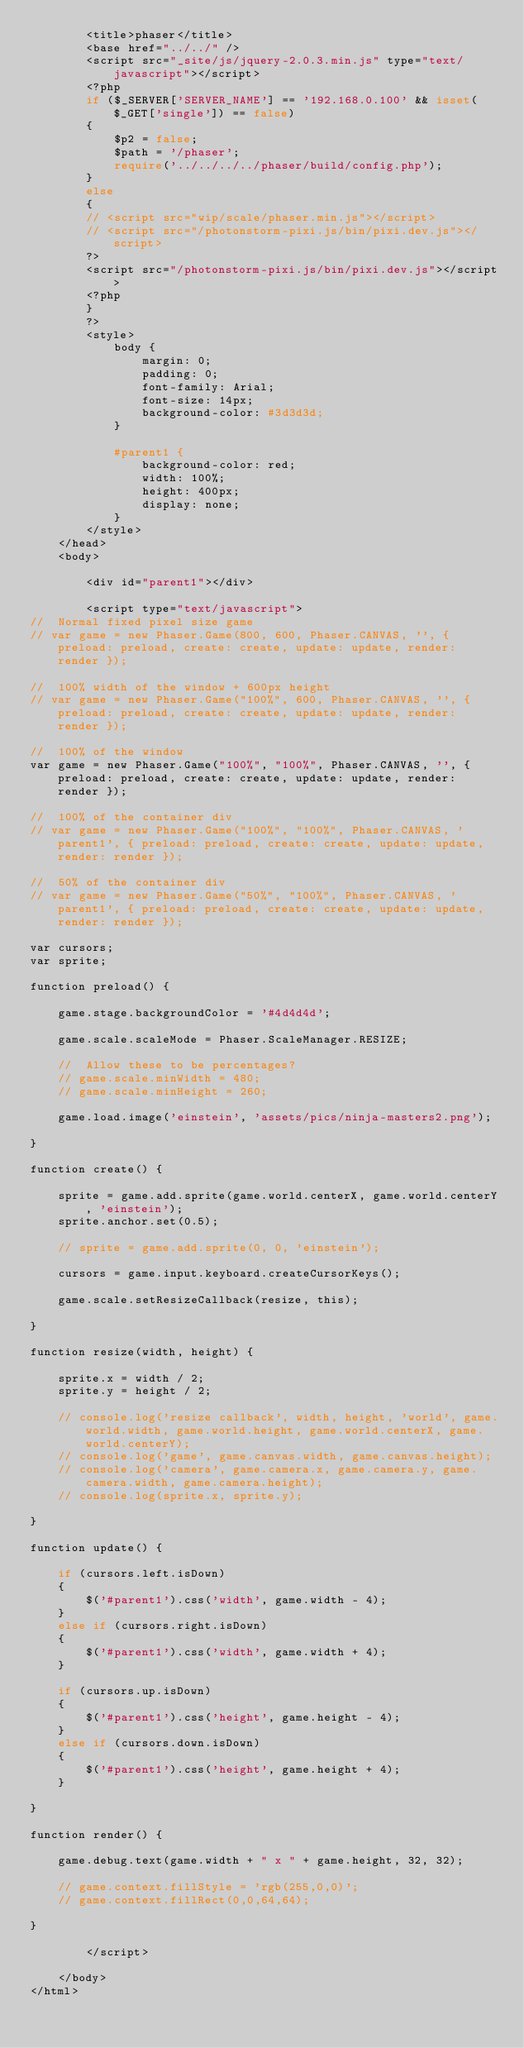Convert code to text. <code><loc_0><loc_0><loc_500><loc_500><_PHP_>        <title>phaser</title>
        <base href="../../" />
        <script src="_site/js/jquery-2.0.3.min.js" type="text/javascript"></script>
        <?php
        if ($_SERVER['SERVER_NAME'] == '192.168.0.100' && isset($_GET['single']) == false)
        {
            $p2 = false;
            $path = '/phaser';
            require('../../../../phaser/build/config.php');
        }
        else
        {
        // <script src="wip/scale/phaser.min.js"></script>
        // <script src="/photonstorm-pixi.js/bin/pixi.dev.js"></script>
        ?>
        <script src="/photonstorm-pixi.js/bin/pixi.dev.js"></script>
        <?php
        }
        ?>
        <style>
            body {
                margin: 0;
                padding: 0;
                font-family: Arial;
                font-size: 14px;
                background-color: #3d3d3d;
            }

            #parent1 {
                background-color: red;
                width: 100%;
                height: 400px;
                display: none;
            }
        </style>
    </head>
    <body>

        <div id="parent1"></div>

        <script type="text/javascript">
//  Normal fixed pixel size game
// var game = new Phaser.Game(800, 600, Phaser.CANVAS, '', { preload: preload, create: create, update: update, render: render });

//  100% width of the window + 600px height
// var game = new Phaser.Game("100%", 600, Phaser.CANVAS, '', { preload: preload, create: create, update: update, render: render });

//  100% of the window
var game = new Phaser.Game("100%", "100%", Phaser.CANVAS, '', { preload: preload, create: create, update: update, render: render });

//  100% of the container div
// var game = new Phaser.Game("100%", "100%", Phaser.CANVAS, 'parent1', { preload: preload, create: create, update: update, render: render });

//  50% of the container div
// var game = new Phaser.Game("50%", "100%", Phaser.CANVAS, 'parent1', { preload: preload, create: create, update: update, render: render });

var cursors;
var sprite;

function preload() {

    game.stage.backgroundColor = '#4d4d4d';

    game.scale.scaleMode = Phaser.ScaleManager.RESIZE;

    //  Allow these to be percentages?
    // game.scale.minWidth = 480;
    // game.scale.minHeight = 260;

    game.load.image('einstein', 'assets/pics/ninja-masters2.png');

}

function create() {

    sprite = game.add.sprite(game.world.centerX, game.world.centerY, 'einstein');
    sprite.anchor.set(0.5);

    // sprite = game.add.sprite(0, 0, 'einstein');

    cursors = game.input.keyboard.createCursorKeys();

    game.scale.setResizeCallback(resize, this);

}

function resize(width, height) {

    sprite.x = width / 2;
    sprite.y = height / 2;

    // console.log('resize callback', width, height, 'world', game.world.width, game.world.height, game.world.centerX, game.world.centerY);
    // console.log('game', game.canvas.width, game.canvas.height);
    // console.log('camera', game.camera.x, game.camera.y, game.camera.width, game.camera.height);
    // console.log(sprite.x, sprite.y);

}

function update() {

    if (cursors.left.isDown)
    {
        $('#parent1').css('width', game.width - 4);
    }
    else if (cursors.right.isDown)
    {
        $('#parent1').css('width', game.width + 4);
    }

    if (cursors.up.isDown)
    {
        $('#parent1').css('height', game.height - 4);
    }
    else if (cursors.down.isDown)
    {
        $('#parent1').css('height', game.height + 4);
    }

}
       
function render() {

    game.debug.text(game.width + " x " + game.height, 32, 32);

    // game.context.fillStyle = 'rgb(255,0,0)';
    // game.context.fillRect(0,0,64,64);

}

        </script>

    </body>
</html></code> 